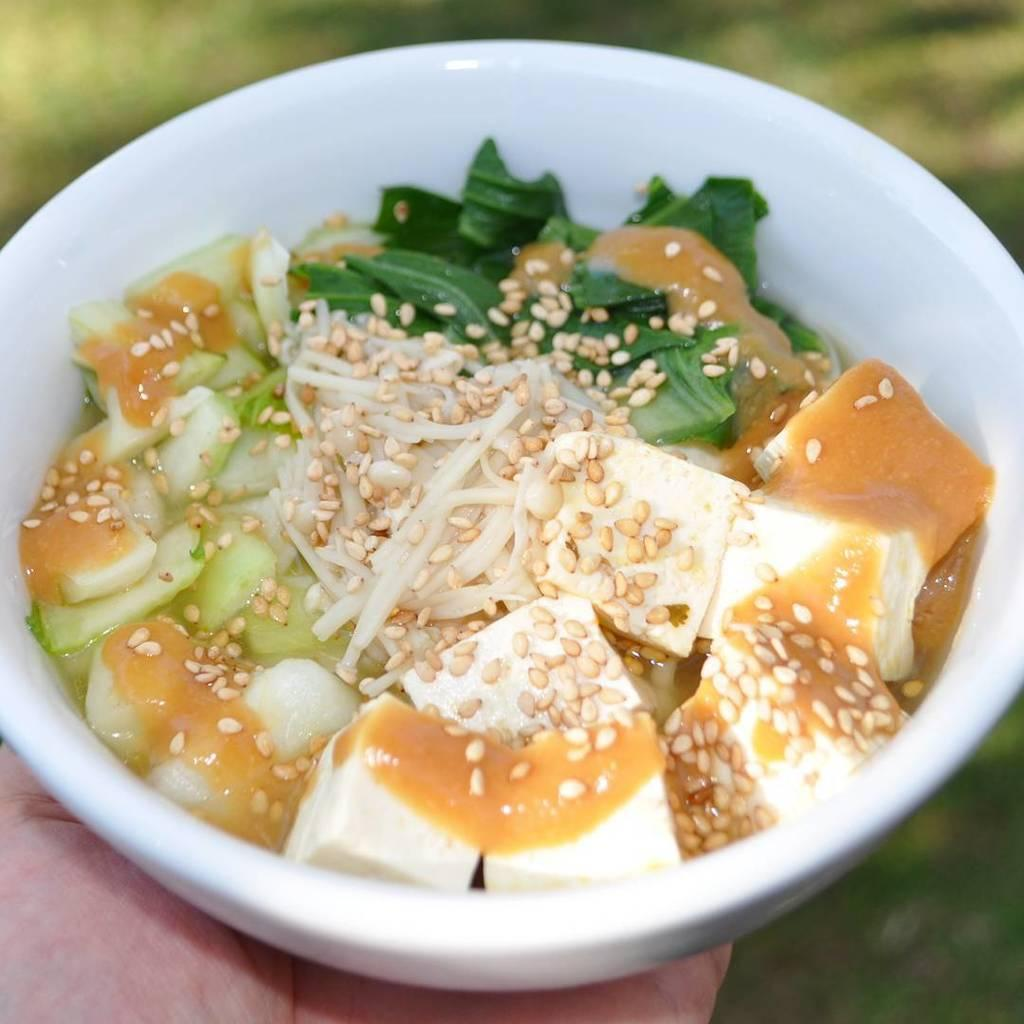What is the main subject of the image? There is a person in the image. What is the person holding in the image? The person is holding a bowl. What is inside the bowl? There is food in the bowl. Can you describe the background of the image? The background of the image is blurry. Can you tell me how many shoes the person is wearing in the image? There is no information about shoes in the image, as the focus is on the person holding a bowl with food. 